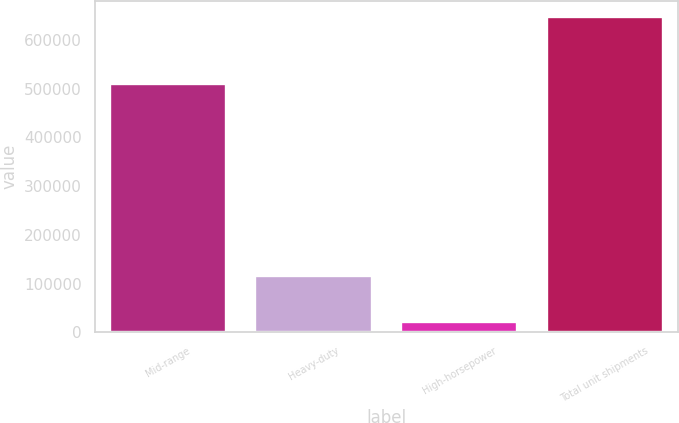<chart> <loc_0><loc_0><loc_500><loc_500><bar_chart><fcel>Mid-range<fcel>Heavy-duty<fcel>High-horsepower<fcel>Total unit shipments<nl><fcel>509400<fcel>116300<fcel>21600<fcel>647300<nl></chart> 